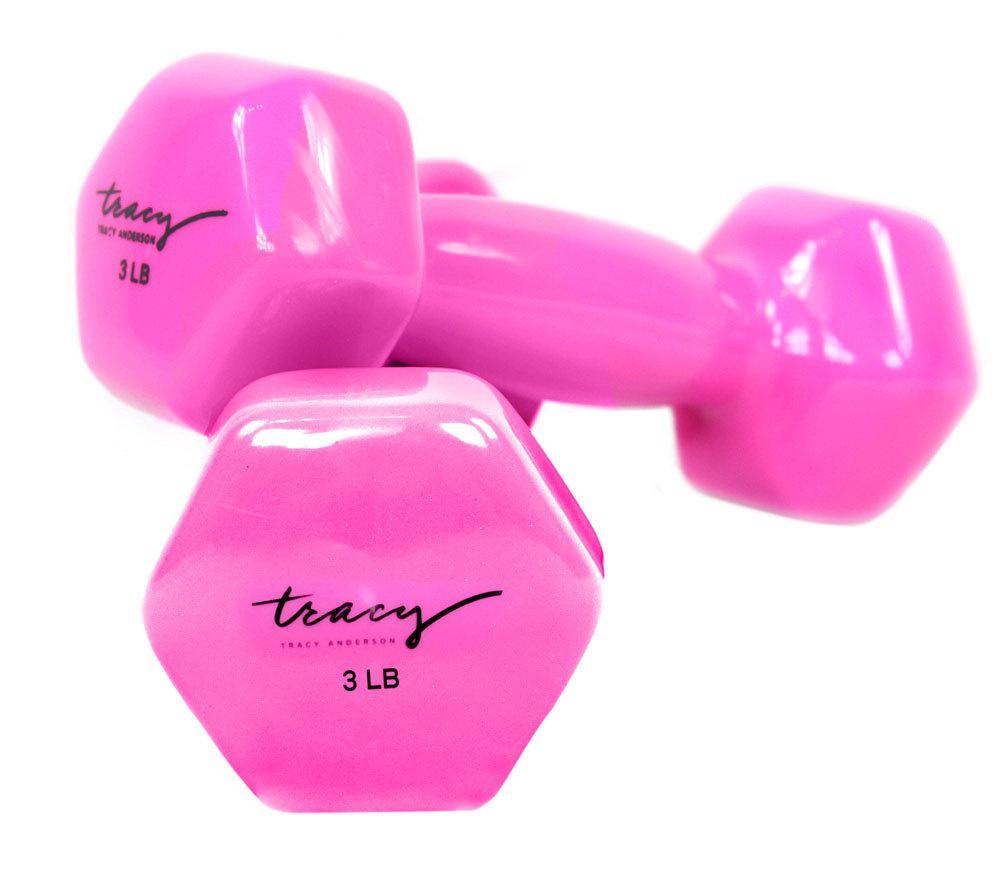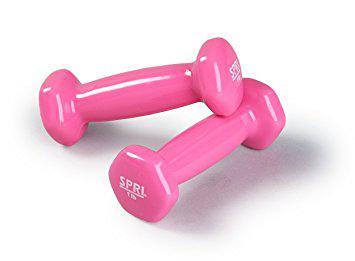The first image is the image on the left, the second image is the image on the right. Examine the images to the left and right. Is the description "There are four dumbbells." accurate? Answer yes or no. Yes. The first image is the image on the left, the second image is the image on the right. Considering the images on both sides, is "In each image, one dumbbell is leaning against another." valid? Answer yes or no. Yes. 